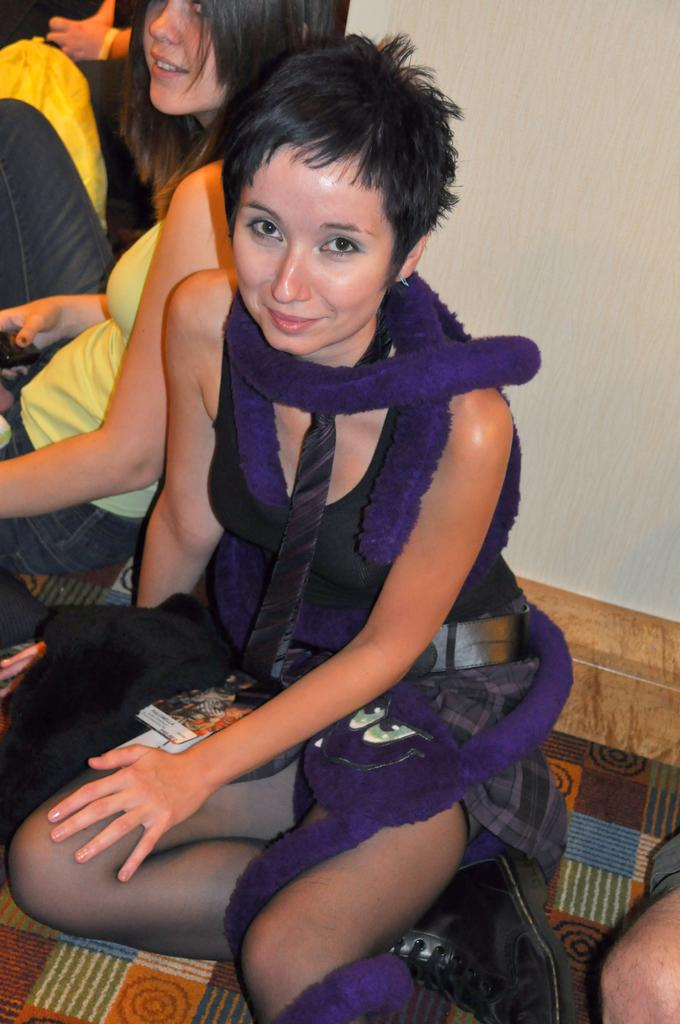Who is present in the image? There are women in the image. What are the women doing in the image? The women are sitting. What expression do the women have in the image? The women are smiling. What can be seen in the background of the image? There is a wall visible in the background of the image. What type of regret can be seen on the women's faces in the image? There is no indication of regret on the women's faces in the image; they are smiling. What color is the gold object that the women are holding in the image? There is no gold object present in the image. 